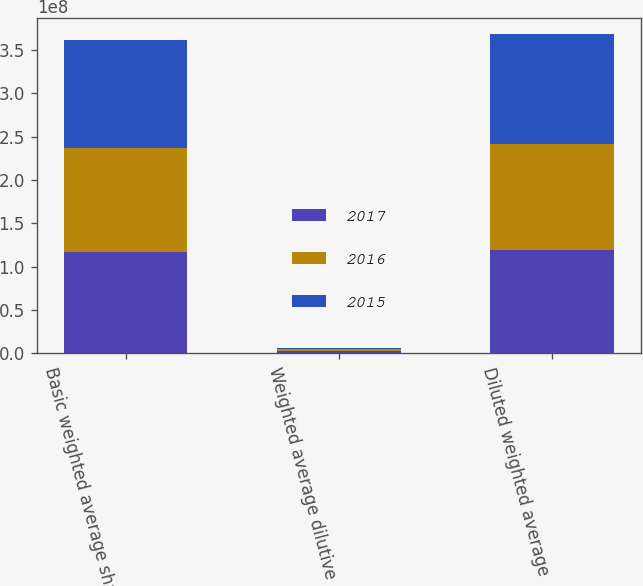Convert chart to OTSL. <chart><loc_0><loc_0><loc_500><loc_500><stacked_bar_chart><ecel><fcel>Basic weighted average shares<fcel>Weighted average dilutive<fcel>Diluted weighted average<nl><fcel>2017<fcel>1.16343e+08<fcel>2.64096e+06<fcel>1.18983e+08<nl><fcel>2016<fcel>1.20001e+08<fcel>2.36659e+06<fcel>1.22368e+08<nl><fcel>2015<fcel>1.25095e+08<fcel>1.66261e+06<fcel>1.26757e+08<nl></chart> 